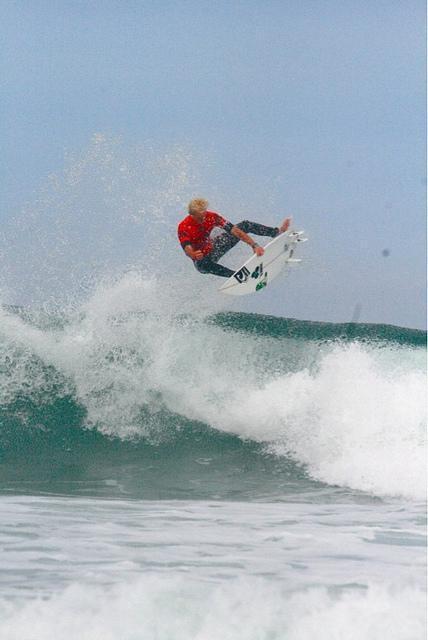How many dogs have a frisbee in their mouth?
Give a very brief answer. 0. 